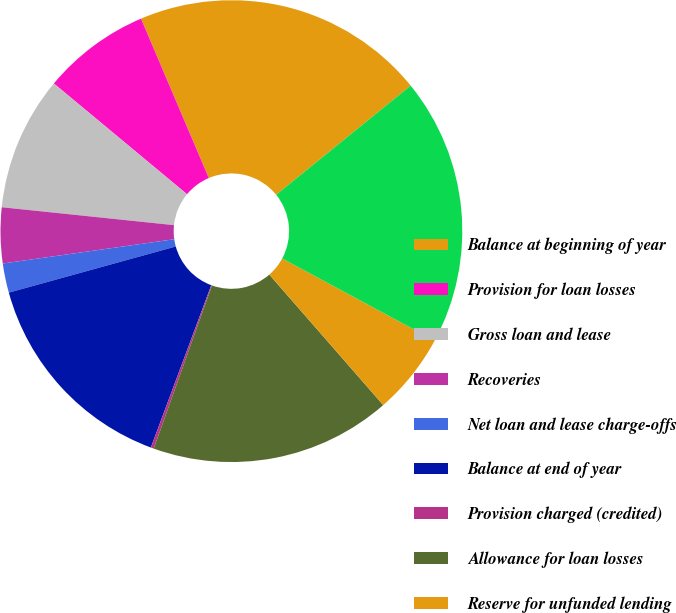Convert chart. <chart><loc_0><loc_0><loc_500><loc_500><pie_chart><fcel>Balance at beginning of year<fcel>Provision for loan losses<fcel>Gross loan and lease<fcel>Recoveries<fcel>Net loan and lease charge-offs<fcel>Balance at end of year<fcel>Provision charged (credited)<fcel>Allowance for loan losses<fcel>Reserve for unfunded lending<fcel>Total allowance for credit<nl><fcel>20.55%<fcel>7.56%<fcel>9.39%<fcel>3.89%<fcel>2.05%<fcel>15.04%<fcel>0.21%<fcel>16.88%<fcel>5.72%<fcel>18.71%<nl></chart> 